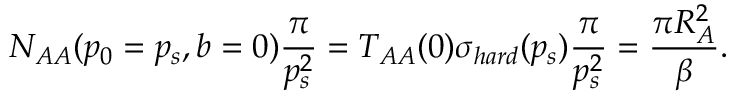<formula> <loc_0><loc_0><loc_500><loc_500>N _ { A A } ( p _ { 0 } = p _ { s } , b = 0 ) \frac { \pi } { p _ { s } ^ { 2 } } = T _ { A A } ( 0 ) \sigma _ { h a r d } ( p _ { s } ) \frac { \pi } { p _ { s } ^ { 2 } } = \frac { \pi R _ { A } ^ { 2 } } { \beta } .</formula> 